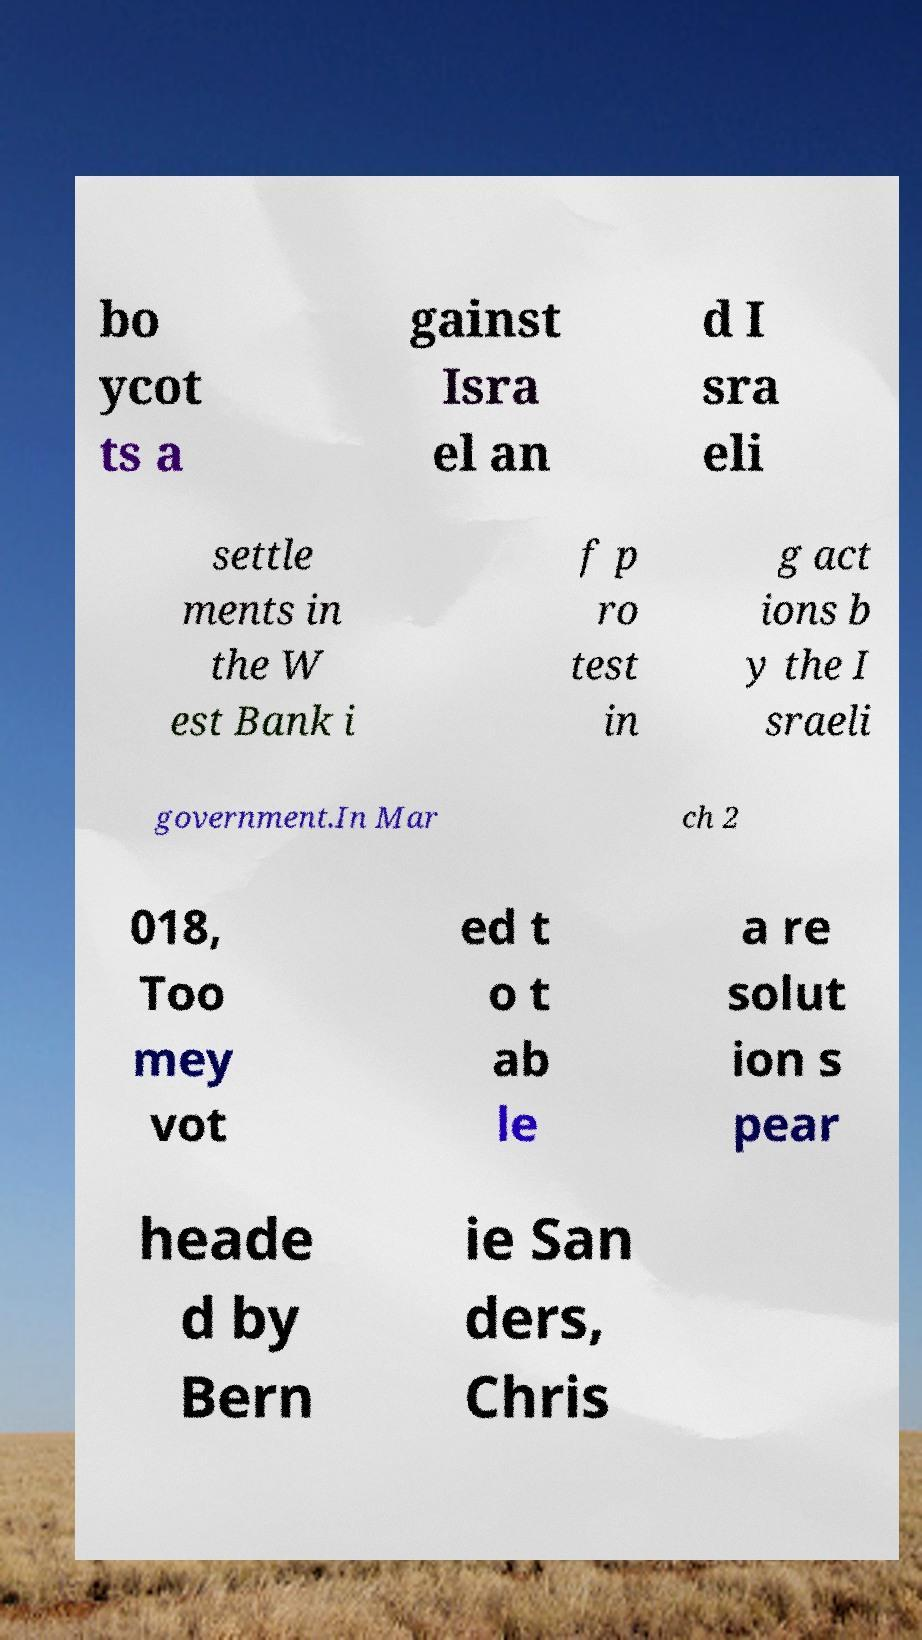Please identify and transcribe the text found in this image. bo ycot ts a gainst Isra el an d I sra eli settle ments in the W est Bank i f p ro test in g act ions b y the I sraeli government.In Mar ch 2 018, Too mey vot ed t o t ab le a re solut ion s pear heade d by Bern ie San ders, Chris 